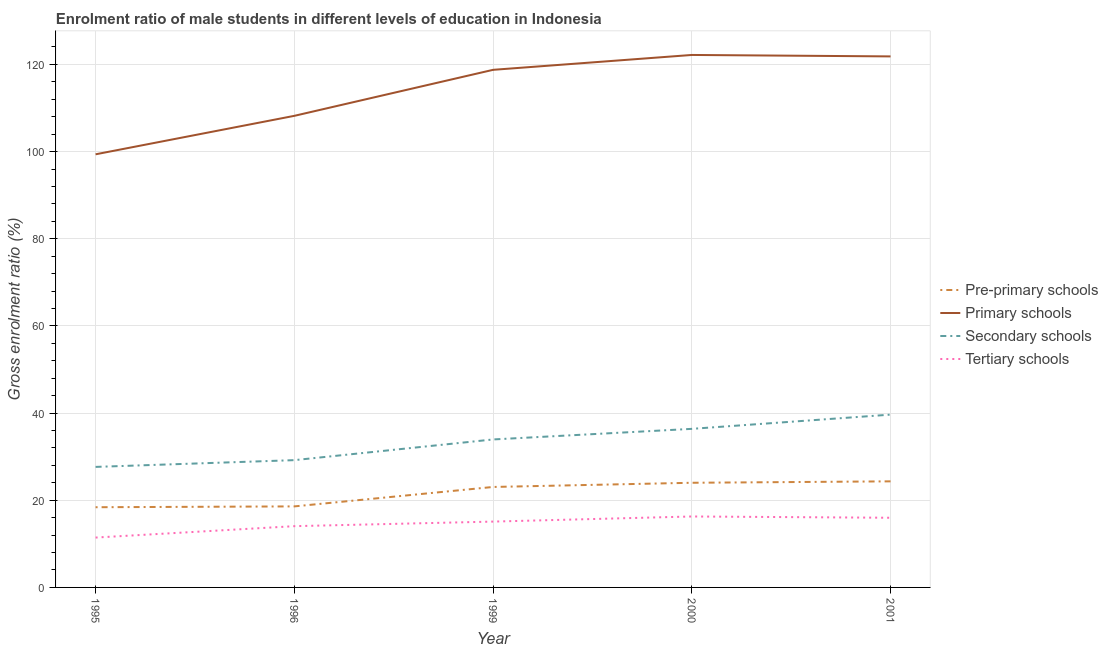Does the line corresponding to gross enrolment ratio(female) in secondary schools intersect with the line corresponding to gross enrolment ratio(female) in primary schools?
Your response must be concise. No. Is the number of lines equal to the number of legend labels?
Make the answer very short. Yes. What is the gross enrolment ratio(female) in pre-primary schools in 2001?
Your answer should be very brief. 24.34. Across all years, what is the maximum gross enrolment ratio(female) in pre-primary schools?
Keep it short and to the point. 24.34. Across all years, what is the minimum gross enrolment ratio(female) in secondary schools?
Make the answer very short. 27.65. In which year was the gross enrolment ratio(female) in primary schools maximum?
Your response must be concise. 2000. In which year was the gross enrolment ratio(female) in primary schools minimum?
Keep it short and to the point. 1995. What is the total gross enrolment ratio(female) in tertiary schools in the graph?
Offer a terse response. 72.86. What is the difference between the gross enrolment ratio(female) in primary schools in 1999 and that in 2001?
Provide a succinct answer. -3.08. What is the difference between the gross enrolment ratio(female) in secondary schools in 1996 and the gross enrolment ratio(female) in primary schools in 1995?
Ensure brevity in your answer.  -70.17. What is the average gross enrolment ratio(female) in tertiary schools per year?
Offer a very short reply. 14.57. In the year 2001, what is the difference between the gross enrolment ratio(female) in pre-primary schools and gross enrolment ratio(female) in tertiary schools?
Your answer should be very brief. 8.36. In how many years, is the gross enrolment ratio(female) in pre-primary schools greater than 16 %?
Keep it short and to the point. 5. What is the ratio of the gross enrolment ratio(female) in tertiary schools in 1995 to that in 2001?
Offer a very short reply. 0.72. Is the difference between the gross enrolment ratio(female) in secondary schools in 1995 and 2001 greater than the difference between the gross enrolment ratio(female) in pre-primary schools in 1995 and 2001?
Provide a succinct answer. No. What is the difference between the highest and the second highest gross enrolment ratio(female) in primary schools?
Your answer should be compact. 0.33. What is the difference between the highest and the lowest gross enrolment ratio(female) in secondary schools?
Your response must be concise. 12. In how many years, is the gross enrolment ratio(female) in secondary schools greater than the average gross enrolment ratio(female) in secondary schools taken over all years?
Ensure brevity in your answer.  3. Is it the case that in every year, the sum of the gross enrolment ratio(female) in pre-primary schools and gross enrolment ratio(female) in primary schools is greater than the gross enrolment ratio(female) in secondary schools?
Your response must be concise. Yes. Is the gross enrolment ratio(female) in pre-primary schools strictly greater than the gross enrolment ratio(female) in secondary schools over the years?
Ensure brevity in your answer.  No. How many lines are there?
Offer a very short reply. 4. How many years are there in the graph?
Your response must be concise. 5. Are the values on the major ticks of Y-axis written in scientific E-notation?
Make the answer very short. No. Does the graph contain any zero values?
Provide a succinct answer. No. How many legend labels are there?
Your answer should be compact. 4. What is the title of the graph?
Offer a terse response. Enrolment ratio of male students in different levels of education in Indonesia. What is the label or title of the Y-axis?
Offer a very short reply. Gross enrolment ratio (%). What is the Gross enrolment ratio (%) in Pre-primary schools in 1995?
Make the answer very short. 18.4. What is the Gross enrolment ratio (%) of Primary schools in 1995?
Your response must be concise. 99.37. What is the Gross enrolment ratio (%) of Secondary schools in 1995?
Provide a short and direct response. 27.65. What is the Gross enrolment ratio (%) of Tertiary schools in 1995?
Your response must be concise. 11.44. What is the Gross enrolment ratio (%) of Pre-primary schools in 1996?
Make the answer very short. 18.59. What is the Gross enrolment ratio (%) in Primary schools in 1996?
Your answer should be very brief. 108.2. What is the Gross enrolment ratio (%) of Secondary schools in 1996?
Provide a short and direct response. 29.2. What is the Gross enrolment ratio (%) of Tertiary schools in 1996?
Provide a succinct answer. 14.06. What is the Gross enrolment ratio (%) of Pre-primary schools in 1999?
Keep it short and to the point. 23.05. What is the Gross enrolment ratio (%) in Primary schools in 1999?
Your response must be concise. 118.75. What is the Gross enrolment ratio (%) of Secondary schools in 1999?
Your response must be concise. 33.95. What is the Gross enrolment ratio (%) in Tertiary schools in 1999?
Give a very brief answer. 15.11. What is the Gross enrolment ratio (%) in Pre-primary schools in 2000?
Provide a short and direct response. 24.01. What is the Gross enrolment ratio (%) in Primary schools in 2000?
Your answer should be very brief. 122.17. What is the Gross enrolment ratio (%) of Secondary schools in 2000?
Your answer should be compact. 36.38. What is the Gross enrolment ratio (%) in Tertiary schools in 2000?
Your answer should be very brief. 16.28. What is the Gross enrolment ratio (%) of Pre-primary schools in 2001?
Provide a short and direct response. 24.34. What is the Gross enrolment ratio (%) of Primary schools in 2001?
Make the answer very short. 121.83. What is the Gross enrolment ratio (%) of Secondary schools in 2001?
Offer a terse response. 39.65. What is the Gross enrolment ratio (%) of Tertiary schools in 2001?
Make the answer very short. 15.98. Across all years, what is the maximum Gross enrolment ratio (%) in Pre-primary schools?
Give a very brief answer. 24.34. Across all years, what is the maximum Gross enrolment ratio (%) in Primary schools?
Make the answer very short. 122.17. Across all years, what is the maximum Gross enrolment ratio (%) of Secondary schools?
Make the answer very short. 39.65. Across all years, what is the maximum Gross enrolment ratio (%) in Tertiary schools?
Your response must be concise. 16.28. Across all years, what is the minimum Gross enrolment ratio (%) in Pre-primary schools?
Your answer should be compact. 18.4. Across all years, what is the minimum Gross enrolment ratio (%) in Primary schools?
Offer a terse response. 99.37. Across all years, what is the minimum Gross enrolment ratio (%) of Secondary schools?
Offer a terse response. 27.65. Across all years, what is the minimum Gross enrolment ratio (%) of Tertiary schools?
Keep it short and to the point. 11.44. What is the total Gross enrolment ratio (%) of Pre-primary schools in the graph?
Your answer should be compact. 108.39. What is the total Gross enrolment ratio (%) in Primary schools in the graph?
Offer a very short reply. 570.33. What is the total Gross enrolment ratio (%) of Secondary schools in the graph?
Ensure brevity in your answer.  166.84. What is the total Gross enrolment ratio (%) in Tertiary schools in the graph?
Provide a succinct answer. 72.86. What is the difference between the Gross enrolment ratio (%) of Pre-primary schools in 1995 and that in 1996?
Offer a very short reply. -0.19. What is the difference between the Gross enrolment ratio (%) in Primary schools in 1995 and that in 1996?
Provide a succinct answer. -8.83. What is the difference between the Gross enrolment ratio (%) of Secondary schools in 1995 and that in 1996?
Provide a short and direct response. -1.55. What is the difference between the Gross enrolment ratio (%) of Tertiary schools in 1995 and that in 1996?
Your response must be concise. -2.62. What is the difference between the Gross enrolment ratio (%) of Pre-primary schools in 1995 and that in 1999?
Make the answer very short. -4.65. What is the difference between the Gross enrolment ratio (%) of Primary schools in 1995 and that in 1999?
Give a very brief answer. -19.38. What is the difference between the Gross enrolment ratio (%) of Secondary schools in 1995 and that in 1999?
Your answer should be very brief. -6.3. What is the difference between the Gross enrolment ratio (%) in Tertiary schools in 1995 and that in 1999?
Provide a succinct answer. -3.66. What is the difference between the Gross enrolment ratio (%) of Pre-primary schools in 1995 and that in 2000?
Provide a succinct answer. -5.61. What is the difference between the Gross enrolment ratio (%) of Primary schools in 1995 and that in 2000?
Make the answer very short. -22.79. What is the difference between the Gross enrolment ratio (%) of Secondary schools in 1995 and that in 2000?
Your answer should be compact. -8.73. What is the difference between the Gross enrolment ratio (%) in Tertiary schools in 1995 and that in 2000?
Make the answer very short. -4.84. What is the difference between the Gross enrolment ratio (%) of Pre-primary schools in 1995 and that in 2001?
Provide a short and direct response. -5.94. What is the difference between the Gross enrolment ratio (%) of Primary schools in 1995 and that in 2001?
Provide a short and direct response. -22.46. What is the difference between the Gross enrolment ratio (%) of Secondary schools in 1995 and that in 2001?
Offer a terse response. -12. What is the difference between the Gross enrolment ratio (%) of Tertiary schools in 1995 and that in 2001?
Ensure brevity in your answer.  -4.54. What is the difference between the Gross enrolment ratio (%) in Pre-primary schools in 1996 and that in 1999?
Offer a terse response. -4.46. What is the difference between the Gross enrolment ratio (%) of Primary schools in 1996 and that in 1999?
Provide a succinct answer. -10.56. What is the difference between the Gross enrolment ratio (%) in Secondary schools in 1996 and that in 1999?
Provide a succinct answer. -4.75. What is the difference between the Gross enrolment ratio (%) of Tertiary schools in 1996 and that in 1999?
Your response must be concise. -1.05. What is the difference between the Gross enrolment ratio (%) of Pre-primary schools in 1996 and that in 2000?
Make the answer very short. -5.42. What is the difference between the Gross enrolment ratio (%) in Primary schools in 1996 and that in 2000?
Your answer should be very brief. -13.97. What is the difference between the Gross enrolment ratio (%) of Secondary schools in 1996 and that in 2000?
Provide a succinct answer. -7.18. What is the difference between the Gross enrolment ratio (%) of Tertiary schools in 1996 and that in 2000?
Offer a terse response. -2.22. What is the difference between the Gross enrolment ratio (%) in Pre-primary schools in 1996 and that in 2001?
Your answer should be compact. -5.75. What is the difference between the Gross enrolment ratio (%) of Primary schools in 1996 and that in 2001?
Provide a succinct answer. -13.64. What is the difference between the Gross enrolment ratio (%) in Secondary schools in 1996 and that in 2001?
Your answer should be compact. -10.44. What is the difference between the Gross enrolment ratio (%) in Tertiary schools in 1996 and that in 2001?
Offer a very short reply. -1.93. What is the difference between the Gross enrolment ratio (%) of Pre-primary schools in 1999 and that in 2000?
Offer a very short reply. -0.96. What is the difference between the Gross enrolment ratio (%) in Primary schools in 1999 and that in 2000?
Offer a very short reply. -3.41. What is the difference between the Gross enrolment ratio (%) in Secondary schools in 1999 and that in 2000?
Your answer should be compact. -2.43. What is the difference between the Gross enrolment ratio (%) in Tertiary schools in 1999 and that in 2000?
Your answer should be very brief. -1.17. What is the difference between the Gross enrolment ratio (%) in Pre-primary schools in 1999 and that in 2001?
Keep it short and to the point. -1.29. What is the difference between the Gross enrolment ratio (%) in Primary schools in 1999 and that in 2001?
Your response must be concise. -3.08. What is the difference between the Gross enrolment ratio (%) of Secondary schools in 1999 and that in 2001?
Keep it short and to the point. -5.7. What is the difference between the Gross enrolment ratio (%) of Tertiary schools in 1999 and that in 2001?
Provide a short and direct response. -0.88. What is the difference between the Gross enrolment ratio (%) of Pre-primary schools in 2000 and that in 2001?
Your response must be concise. -0.33. What is the difference between the Gross enrolment ratio (%) in Primary schools in 2000 and that in 2001?
Ensure brevity in your answer.  0.33. What is the difference between the Gross enrolment ratio (%) of Secondary schools in 2000 and that in 2001?
Your answer should be compact. -3.27. What is the difference between the Gross enrolment ratio (%) in Tertiary schools in 2000 and that in 2001?
Offer a very short reply. 0.29. What is the difference between the Gross enrolment ratio (%) in Pre-primary schools in 1995 and the Gross enrolment ratio (%) in Primary schools in 1996?
Offer a very short reply. -89.8. What is the difference between the Gross enrolment ratio (%) of Pre-primary schools in 1995 and the Gross enrolment ratio (%) of Secondary schools in 1996?
Ensure brevity in your answer.  -10.8. What is the difference between the Gross enrolment ratio (%) of Pre-primary schools in 1995 and the Gross enrolment ratio (%) of Tertiary schools in 1996?
Your answer should be compact. 4.35. What is the difference between the Gross enrolment ratio (%) of Primary schools in 1995 and the Gross enrolment ratio (%) of Secondary schools in 1996?
Make the answer very short. 70.17. What is the difference between the Gross enrolment ratio (%) in Primary schools in 1995 and the Gross enrolment ratio (%) in Tertiary schools in 1996?
Keep it short and to the point. 85.32. What is the difference between the Gross enrolment ratio (%) in Secondary schools in 1995 and the Gross enrolment ratio (%) in Tertiary schools in 1996?
Make the answer very short. 13.6. What is the difference between the Gross enrolment ratio (%) of Pre-primary schools in 1995 and the Gross enrolment ratio (%) of Primary schools in 1999?
Give a very brief answer. -100.35. What is the difference between the Gross enrolment ratio (%) of Pre-primary schools in 1995 and the Gross enrolment ratio (%) of Secondary schools in 1999?
Make the answer very short. -15.55. What is the difference between the Gross enrolment ratio (%) of Pre-primary schools in 1995 and the Gross enrolment ratio (%) of Tertiary schools in 1999?
Offer a very short reply. 3.3. What is the difference between the Gross enrolment ratio (%) of Primary schools in 1995 and the Gross enrolment ratio (%) of Secondary schools in 1999?
Ensure brevity in your answer.  65.42. What is the difference between the Gross enrolment ratio (%) in Primary schools in 1995 and the Gross enrolment ratio (%) in Tertiary schools in 1999?
Provide a succinct answer. 84.27. What is the difference between the Gross enrolment ratio (%) of Secondary schools in 1995 and the Gross enrolment ratio (%) of Tertiary schools in 1999?
Offer a terse response. 12.55. What is the difference between the Gross enrolment ratio (%) in Pre-primary schools in 1995 and the Gross enrolment ratio (%) in Primary schools in 2000?
Give a very brief answer. -103.77. What is the difference between the Gross enrolment ratio (%) of Pre-primary schools in 1995 and the Gross enrolment ratio (%) of Secondary schools in 2000?
Offer a terse response. -17.98. What is the difference between the Gross enrolment ratio (%) of Pre-primary schools in 1995 and the Gross enrolment ratio (%) of Tertiary schools in 2000?
Make the answer very short. 2.12. What is the difference between the Gross enrolment ratio (%) of Primary schools in 1995 and the Gross enrolment ratio (%) of Secondary schools in 2000?
Your answer should be compact. 62.99. What is the difference between the Gross enrolment ratio (%) in Primary schools in 1995 and the Gross enrolment ratio (%) in Tertiary schools in 2000?
Ensure brevity in your answer.  83.1. What is the difference between the Gross enrolment ratio (%) of Secondary schools in 1995 and the Gross enrolment ratio (%) of Tertiary schools in 2000?
Offer a terse response. 11.38. What is the difference between the Gross enrolment ratio (%) in Pre-primary schools in 1995 and the Gross enrolment ratio (%) in Primary schools in 2001?
Your response must be concise. -103.43. What is the difference between the Gross enrolment ratio (%) in Pre-primary schools in 1995 and the Gross enrolment ratio (%) in Secondary schools in 2001?
Offer a very short reply. -21.25. What is the difference between the Gross enrolment ratio (%) of Pre-primary schools in 1995 and the Gross enrolment ratio (%) of Tertiary schools in 2001?
Make the answer very short. 2.42. What is the difference between the Gross enrolment ratio (%) of Primary schools in 1995 and the Gross enrolment ratio (%) of Secondary schools in 2001?
Offer a terse response. 59.73. What is the difference between the Gross enrolment ratio (%) of Primary schools in 1995 and the Gross enrolment ratio (%) of Tertiary schools in 2001?
Offer a very short reply. 83.39. What is the difference between the Gross enrolment ratio (%) in Secondary schools in 1995 and the Gross enrolment ratio (%) in Tertiary schools in 2001?
Give a very brief answer. 11.67. What is the difference between the Gross enrolment ratio (%) in Pre-primary schools in 1996 and the Gross enrolment ratio (%) in Primary schools in 1999?
Offer a terse response. -100.16. What is the difference between the Gross enrolment ratio (%) in Pre-primary schools in 1996 and the Gross enrolment ratio (%) in Secondary schools in 1999?
Offer a very short reply. -15.36. What is the difference between the Gross enrolment ratio (%) of Pre-primary schools in 1996 and the Gross enrolment ratio (%) of Tertiary schools in 1999?
Your answer should be compact. 3.49. What is the difference between the Gross enrolment ratio (%) of Primary schools in 1996 and the Gross enrolment ratio (%) of Secondary schools in 1999?
Ensure brevity in your answer.  74.25. What is the difference between the Gross enrolment ratio (%) in Primary schools in 1996 and the Gross enrolment ratio (%) in Tertiary schools in 1999?
Provide a short and direct response. 93.09. What is the difference between the Gross enrolment ratio (%) in Secondary schools in 1996 and the Gross enrolment ratio (%) in Tertiary schools in 1999?
Your response must be concise. 14.1. What is the difference between the Gross enrolment ratio (%) in Pre-primary schools in 1996 and the Gross enrolment ratio (%) in Primary schools in 2000?
Ensure brevity in your answer.  -103.58. What is the difference between the Gross enrolment ratio (%) of Pre-primary schools in 1996 and the Gross enrolment ratio (%) of Secondary schools in 2000?
Provide a short and direct response. -17.79. What is the difference between the Gross enrolment ratio (%) in Pre-primary schools in 1996 and the Gross enrolment ratio (%) in Tertiary schools in 2000?
Provide a succinct answer. 2.31. What is the difference between the Gross enrolment ratio (%) in Primary schools in 1996 and the Gross enrolment ratio (%) in Secondary schools in 2000?
Give a very brief answer. 71.82. What is the difference between the Gross enrolment ratio (%) in Primary schools in 1996 and the Gross enrolment ratio (%) in Tertiary schools in 2000?
Your answer should be compact. 91.92. What is the difference between the Gross enrolment ratio (%) in Secondary schools in 1996 and the Gross enrolment ratio (%) in Tertiary schools in 2000?
Your answer should be compact. 12.93. What is the difference between the Gross enrolment ratio (%) in Pre-primary schools in 1996 and the Gross enrolment ratio (%) in Primary schools in 2001?
Ensure brevity in your answer.  -103.24. What is the difference between the Gross enrolment ratio (%) in Pre-primary schools in 1996 and the Gross enrolment ratio (%) in Secondary schools in 2001?
Provide a succinct answer. -21.06. What is the difference between the Gross enrolment ratio (%) in Pre-primary schools in 1996 and the Gross enrolment ratio (%) in Tertiary schools in 2001?
Make the answer very short. 2.61. What is the difference between the Gross enrolment ratio (%) of Primary schools in 1996 and the Gross enrolment ratio (%) of Secondary schools in 2001?
Ensure brevity in your answer.  68.55. What is the difference between the Gross enrolment ratio (%) in Primary schools in 1996 and the Gross enrolment ratio (%) in Tertiary schools in 2001?
Give a very brief answer. 92.22. What is the difference between the Gross enrolment ratio (%) in Secondary schools in 1996 and the Gross enrolment ratio (%) in Tertiary schools in 2001?
Keep it short and to the point. 13.22. What is the difference between the Gross enrolment ratio (%) of Pre-primary schools in 1999 and the Gross enrolment ratio (%) of Primary schools in 2000?
Your answer should be compact. -99.12. What is the difference between the Gross enrolment ratio (%) of Pre-primary schools in 1999 and the Gross enrolment ratio (%) of Secondary schools in 2000?
Ensure brevity in your answer.  -13.33. What is the difference between the Gross enrolment ratio (%) in Pre-primary schools in 1999 and the Gross enrolment ratio (%) in Tertiary schools in 2000?
Offer a very short reply. 6.77. What is the difference between the Gross enrolment ratio (%) in Primary schools in 1999 and the Gross enrolment ratio (%) in Secondary schools in 2000?
Keep it short and to the point. 82.37. What is the difference between the Gross enrolment ratio (%) in Primary schools in 1999 and the Gross enrolment ratio (%) in Tertiary schools in 2000?
Provide a succinct answer. 102.48. What is the difference between the Gross enrolment ratio (%) in Secondary schools in 1999 and the Gross enrolment ratio (%) in Tertiary schools in 2000?
Provide a short and direct response. 17.67. What is the difference between the Gross enrolment ratio (%) in Pre-primary schools in 1999 and the Gross enrolment ratio (%) in Primary schools in 2001?
Ensure brevity in your answer.  -98.78. What is the difference between the Gross enrolment ratio (%) in Pre-primary schools in 1999 and the Gross enrolment ratio (%) in Secondary schools in 2001?
Keep it short and to the point. -16.6. What is the difference between the Gross enrolment ratio (%) in Pre-primary schools in 1999 and the Gross enrolment ratio (%) in Tertiary schools in 2001?
Your answer should be very brief. 7.07. What is the difference between the Gross enrolment ratio (%) in Primary schools in 1999 and the Gross enrolment ratio (%) in Secondary schools in 2001?
Provide a succinct answer. 79.11. What is the difference between the Gross enrolment ratio (%) of Primary schools in 1999 and the Gross enrolment ratio (%) of Tertiary schools in 2001?
Make the answer very short. 102.77. What is the difference between the Gross enrolment ratio (%) in Secondary schools in 1999 and the Gross enrolment ratio (%) in Tertiary schools in 2001?
Offer a very short reply. 17.97. What is the difference between the Gross enrolment ratio (%) in Pre-primary schools in 2000 and the Gross enrolment ratio (%) in Primary schools in 2001?
Provide a succinct answer. -97.82. What is the difference between the Gross enrolment ratio (%) of Pre-primary schools in 2000 and the Gross enrolment ratio (%) of Secondary schools in 2001?
Keep it short and to the point. -15.64. What is the difference between the Gross enrolment ratio (%) of Pre-primary schools in 2000 and the Gross enrolment ratio (%) of Tertiary schools in 2001?
Your answer should be very brief. 8.03. What is the difference between the Gross enrolment ratio (%) of Primary schools in 2000 and the Gross enrolment ratio (%) of Secondary schools in 2001?
Provide a short and direct response. 82.52. What is the difference between the Gross enrolment ratio (%) in Primary schools in 2000 and the Gross enrolment ratio (%) in Tertiary schools in 2001?
Offer a very short reply. 106.18. What is the difference between the Gross enrolment ratio (%) of Secondary schools in 2000 and the Gross enrolment ratio (%) of Tertiary schools in 2001?
Your response must be concise. 20.4. What is the average Gross enrolment ratio (%) of Pre-primary schools per year?
Offer a very short reply. 21.68. What is the average Gross enrolment ratio (%) of Primary schools per year?
Your response must be concise. 114.07. What is the average Gross enrolment ratio (%) in Secondary schools per year?
Give a very brief answer. 33.37. What is the average Gross enrolment ratio (%) of Tertiary schools per year?
Provide a succinct answer. 14.57. In the year 1995, what is the difference between the Gross enrolment ratio (%) in Pre-primary schools and Gross enrolment ratio (%) in Primary schools?
Offer a terse response. -80.97. In the year 1995, what is the difference between the Gross enrolment ratio (%) of Pre-primary schools and Gross enrolment ratio (%) of Secondary schools?
Provide a succinct answer. -9.25. In the year 1995, what is the difference between the Gross enrolment ratio (%) of Pre-primary schools and Gross enrolment ratio (%) of Tertiary schools?
Keep it short and to the point. 6.96. In the year 1995, what is the difference between the Gross enrolment ratio (%) of Primary schools and Gross enrolment ratio (%) of Secondary schools?
Your answer should be very brief. 71.72. In the year 1995, what is the difference between the Gross enrolment ratio (%) of Primary schools and Gross enrolment ratio (%) of Tertiary schools?
Your answer should be compact. 87.93. In the year 1995, what is the difference between the Gross enrolment ratio (%) of Secondary schools and Gross enrolment ratio (%) of Tertiary schools?
Make the answer very short. 16.21. In the year 1996, what is the difference between the Gross enrolment ratio (%) in Pre-primary schools and Gross enrolment ratio (%) in Primary schools?
Your answer should be very brief. -89.61. In the year 1996, what is the difference between the Gross enrolment ratio (%) in Pre-primary schools and Gross enrolment ratio (%) in Secondary schools?
Your answer should be compact. -10.61. In the year 1996, what is the difference between the Gross enrolment ratio (%) of Pre-primary schools and Gross enrolment ratio (%) of Tertiary schools?
Your answer should be compact. 4.54. In the year 1996, what is the difference between the Gross enrolment ratio (%) in Primary schools and Gross enrolment ratio (%) in Secondary schools?
Your answer should be very brief. 79. In the year 1996, what is the difference between the Gross enrolment ratio (%) of Primary schools and Gross enrolment ratio (%) of Tertiary schools?
Keep it short and to the point. 94.14. In the year 1996, what is the difference between the Gross enrolment ratio (%) of Secondary schools and Gross enrolment ratio (%) of Tertiary schools?
Give a very brief answer. 15.15. In the year 1999, what is the difference between the Gross enrolment ratio (%) of Pre-primary schools and Gross enrolment ratio (%) of Primary schools?
Make the answer very short. -95.7. In the year 1999, what is the difference between the Gross enrolment ratio (%) in Pre-primary schools and Gross enrolment ratio (%) in Secondary schools?
Keep it short and to the point. -10.9. In the year 1999, what is the difference between the Gross enrolment ratio (%) of Pre-primary schools and Gross enrolment ratio (%) of Tertiary schools?
Provide a short and direct response. 7.94. In the year 1999, what is the difference between the Gross enrolment ratio (%) in Primary schools and Gross enrolment ratio (%) in Secondary schools?
Ensure brevity in your answer.  84.8. In the year 1999, what is the difference between the Gross enrolment ratio (%) in Primary schools and Gross enrolment ratio (%) in Tertiary schools?
Ensure brevity in your answer.  103.65. In the year 1999, what is the difference between the Gross enrolment ratio (%) in Secondary schools and Gross enrolment ratio (%) in Tertiary schools?
Keep it short and to the point. 18.85. In the year 2000, what is the difference between the Gross enrolment ratio (%) in Pre-primary schools and Gross enrolment ratio (%) in Primary schools?
Your answer should be compact. -98.16. In the year 2000, what is the difference between the Gross enrolment ratio (%) in Pre-primary schools and Gross enrolment ratio (%) in Secondary schools?
Ensure brevity in your answer.  -12.37. In the year 2000, what is the difference between the Gross enrolment ratio (%) of Pre-primary schools and Gross enrolment ratio (%) of Tertiary schools?
Your response must be concise. 7.73. In the year 2000, what is the difference between the Gross enrolment ratio (%) of Primary schools and Gross enrolment ratio (%) of Secondary schools?
Your response must be concise. 85.79. In the year 2000, what is the difference between the Gross enrolment ratio (%) of Primary schools and Gross enrolment ratio (%) of Tertiary schools?
Offer a terse response. 105.89. In the year 2000, what is the difference between the Gross enrolment ratio (%) of Secondary schools and Gross enrolment ratio (%) of Tertiary schools?
Offer a very short reply. 20.1. In the year 2001, what is the difference between the Gross enrolment ratio (%) in Pre-primary schools and Gross enrolment ratio (%) in Primary schools?
Your answer should be very brief. -97.5. In the year 2001, what is the difference between the Gross enrolment ratio (%) in Pre-primary schools and Gross enrolment ratio (%) in Secondary schools?
Provide a succinct answer. -15.31. In the year 2001, what is the difference between the Gross enrolment ratio (%) of Pre-primary schools and Gross enrolment ratio (%) of Tertiary schools?
Offer a terse response. 8.36. In the year 2001, what is the difference between the Gross enrolment ratio (%) of Primary schools and Gross enrolment ratio (%) of Secondary schools?
Offer a terse response. 82.19. In the year 2001, what is the difference between the Gross enrolment ratio (%) in Primary schools and Gross enrolment ratio (%) in Tertiary schools?
Provide a succinct answer. 105.85. In the year 2001, what is the difference between the Gross enrolment ratio (%) of Secondary schools and Gross enrolment ratio (%) of Tertiary schools?
Your answer should be compact. 23.66. What is the ratio of the Gross enrolment ratio (%) in Pre-primary schools in 1995 to that in 1996?
Keep it short and to the point. 0.99. What is the ratio of the Gross enrolment ratio (%) in Primary schools in 1995 to that in 1996?
Keep it short and to the point. 0.92. What is the ratio of the Gross enrolment ratio (%) in Secondary schools in 1995 to that in 1996?
Make the answer very short. 0.95. What is the ratio of the Gross enrolment ratio (%) of Tertiary schools in 1995 to that in 1996?
Your answer should be very brief. 0.81. What is the ratio of the Gross enrolment ratio (%) in Pre-primary schools in 1995 to that in 1999?
Offer a terse response. 0.8. What is the ratio of the Gross enrolment ratio (%) of Primary schools in 1995 to that in 1999?
Your answer should be compact. 0.84. What is the ratio of the Gross enrolment ratio (%) of Secondary schools in 1995 to that in 1999?
Offer a very short reply. 0.81. What is the ratio of the Gross enrolment ratio (%) of Tertiary schools in 1995 to that in 1999?
Offer a terse response. 0.76. What is the ratio of the Gross enrolment ratio (%) of Pre-primary schools in 1995 to that in 2000?
Keep it short and to the point. 0.77. What is the ratio of the Gross enrolment ratio (%) of Primary schools in 1995 to that in 2000?
Provide a short and direct response. 0.81. What is the ratio of the Gross enrolment ratio (%) in Secondary schools in 1995 to that in 2000?
Your answer should be very brief. 0.76. What is the ratio of the Gross enrolment ratio (%) in Tertiary schools in 1995 to that in 2000?
Your answer should be compact. 0.7. What is the ratio of the Gross enrolment ratio (%) in Pre-primary schools in 1995 to that in 2001?
Your response must be concise. 0.76. What is the ratio of the Gross enrolment ratio (%) of Primary schools in 1995 to that in 2001?
Your answer should be compact. 0.82. What is the ratio of the Gross enrolment ratio (%) in Secondary schools in 1995 to that in 2001?
Keep it short and to the point. 0.7. What is the ratio of the Gross enrolment ratio (%) of Tertiary schools in 1995 to that in 2001?
Provide a succinct answer. 0.72. What is the ratio of the Gross enrolment ratio (%) of Pre-primary schools in 1996 to that in 1999?
Give a very brief answer. 0.81. What is the ratio of the Gross enrolment ratio (%) of Primary schools in 1996 to that in 1999?
Offer a very short reply. 0.91. What is the ratio of the Gross enrolment ratio (%) of Secondary schools in 1996 to that in 1999?
Your response must be concise. 0.86. What is the ratio of the Gross enrolment ratio (%) in Tertiary schools in 1996 to that in 1999?
Give a very brief answer. 0.93. What is the ratio of the Gross enrolment ratio (%) of Pre-primary schools in 1996 to that in 2000?
Make the answer very short. 0.77. What is the ratio of the Gross enrolment ratio (%) in Primary schools in 1996 to that in 2000?
Give a very brief answer. 0.89. What is the ratio of the Gross enrolment ratio (%) in Secondary schools in 1996 to that in 2000?
Provide a short and direct response. 0.8. What is the ratio of the Gross enrolment ratio (%) of Tertiary schools in 1996 to that in 2000?
Your answer should be compact. 0.86. What is the ratio of the Gross enrolment ratio (%) in Pre-primary schools in 1996 to that in 2001?
Provide a short and direct response. 0.76. What is the ratio of the Gross enrolment ratio (%) in Primary schools in 1996 to that in 2001?
Offer a terse response. 0.89. What is the ratio of the Gross enrolment ratio (%) in Secondary schools in 1996 to that in 2001?
Your answer should be compact. 0.74. What is the ratio of the Gross enrolment ratio (%) in Tertiary schools in 1996 to that in 2001?
Offer a terse response. 0.88. What is the ratio of the Gross enrolment ratio (%) in Pre-primary schools in 1999 to that in 2000?
Your answer should be compact. 0.96. What is the ratio of the Gross enrolment ratio (%) in Primary schools in 1999 to that in 2000?
Offer a terse response. 0.97. What is the ratio of the Gross enrolment ratio (%) of Secondary schools in 1999 to that in 2000?
Offer a very short reply. 0.93. What is the ratio of the Gross enrolment ratio (%) in Tertiary schools in 1999 to that in 2000?
Offer a terse response. 0.93. What is the ratio of the Gross enrolment ratio (%) in Pre-primary schools in 1999 to that in 2001?
Provide a short and direct response. 0.95. What is the ratio of the Gross enrolment ratio (%) in Primary schools in 1999 to that in 2001?
Your answer should be compact. 0.97. What is the ratio of the Gross enrolment ratio (%) in Secondary schools in 1999 to that in 2001?
Keep it short and to the point. 0.86. What is the ratio of the Gross enrolment ratio (%) of Tertiary schools in 1999 to that in 2001?
Offer a very short reply. 0.94. What is the ratio of the Gross enrolment ratio (%) in Pre-primary schools in 2000 to that in 2001?
Your answer should be compact. 0.99. What is the ratio of the Gross enrolment ratio (%) of Primary schools in 2000 to that in 2001?
Make the answer very short. 1. What is the ratio of the Gross enrolment ratio (%) of Secondary schools in 2000 to that in 2001?
Provide a succinct answer. 0.92. What is the ratio of the Gross enrolment ratio (%) of Tertiary schools in 2000 to that in 2001?
Make the answer very short. 1.02. What is the difference between the highest and the second highest Gross enrolment ratio (%) in Pre-primary schools?
Offer a very short reply. 0.33. What is the difference between the highest and the second highest Gross enrolment ratio (%) of Primary schools?
Give a very brief answer. 0.33. What is the difference between the highest and the second highest Gross enrolment ratio (%) in Secondary schools?
Provide a short and direct response. 3.27. What is the difference between the highest and the second highest Gross enrolment ratio (%) in Tertiary schools?
Your response must be concise. 0.29. What is the difference between the highest and the lowest Gross enrolment ratio (%) of Pre-primary schools?
Give a very brief answer. 5.94. What is the difference between the highest and the lowest Gross enrolment ratio (%) in Primary schools?
Offer a very short reply. 22.79. What is the difference between the highest and the lowest Gross enrolment ratio (%) in Secondary schools?
Offer a terse response. 12. What is the difference between the highest and the lowest Gross enrolment ratio (%) of Tertiary schools?
Provide a succinct answer. 4.84. 